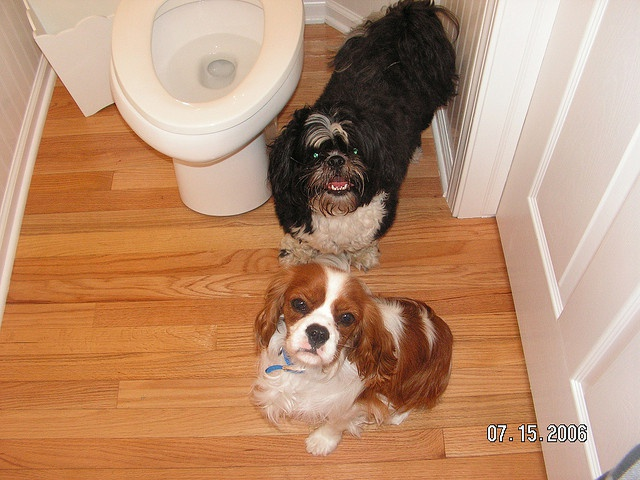Describe the objects in this image and their specific colors. I can see toilet in tan, lightgray, and darkgray tones, dog in tan, black, gray, and maroon tones, and dog in tan, maroon, brown, and gray tones in this image. 